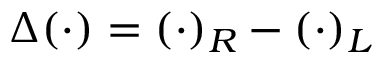<formula> <loc_0><loc_0><loc_500><loc_500>\Delta ( { \cdot } ) = ( { \cdot } ) _ { R } - ( { \cdot } ) _ { L }</formula> 